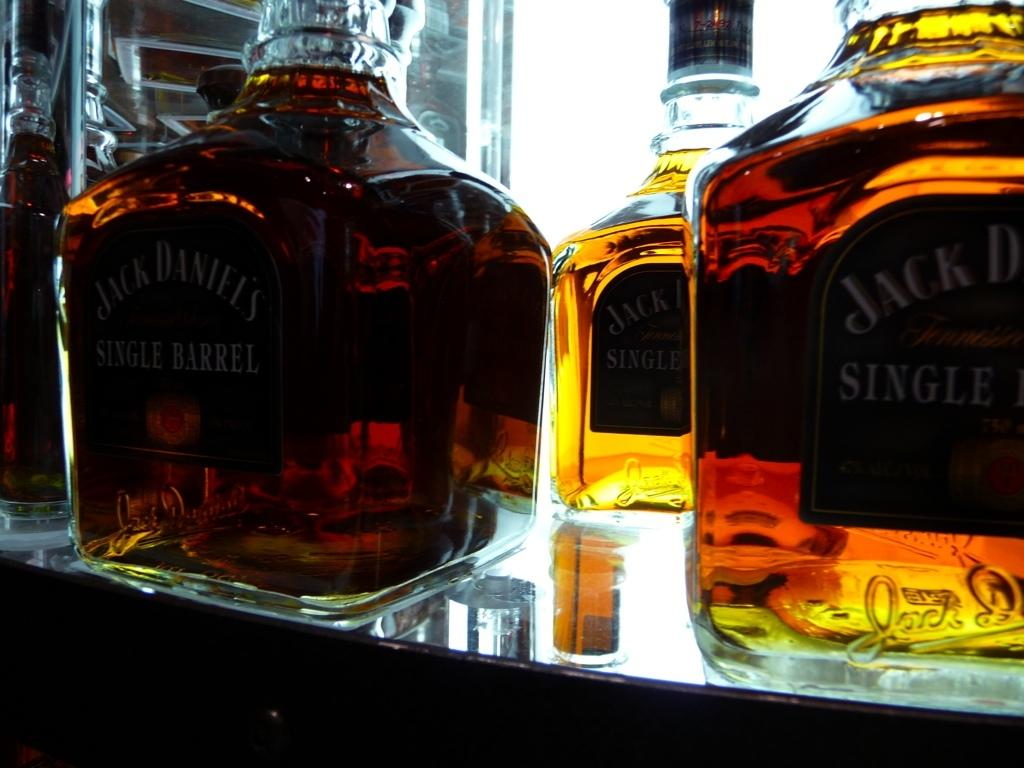<image>
Summarize the visual content of the image. Several bottles of Jack Daniels Single Barrel Whiskey stand on a shelf 